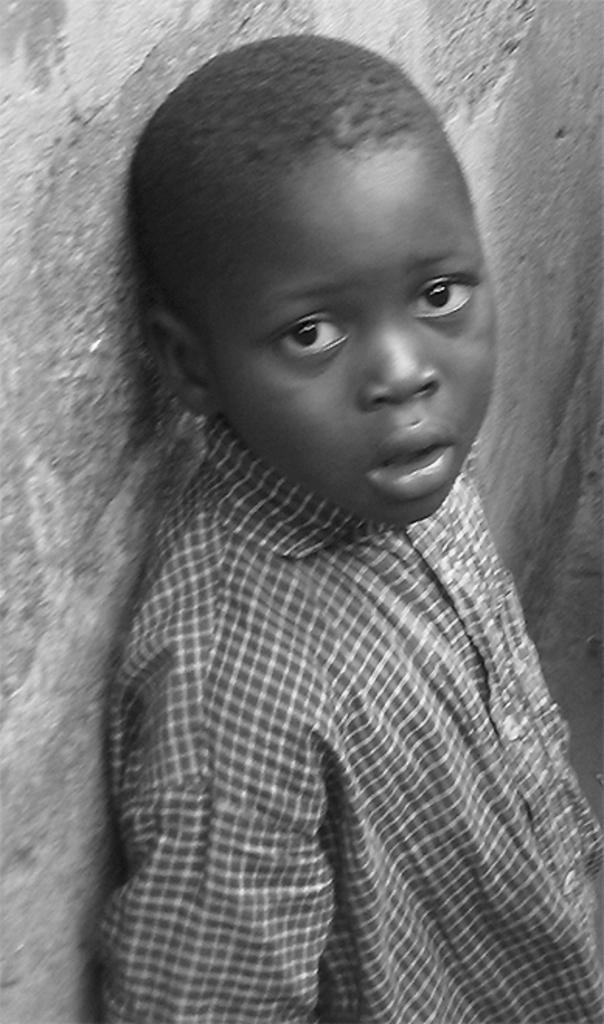How would you summarize this image in a sentence or two? This is a black and white image, in this image there is a boy standing near a wall. 